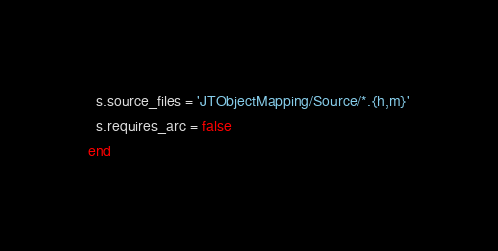<code> <loc_0><loc_0><loc_500><loc_500><_Ruby_>
  s.source_files = 'JTObjectMapping/Source/*.{h,m}'
  s.requires_arc = false
end</code> 